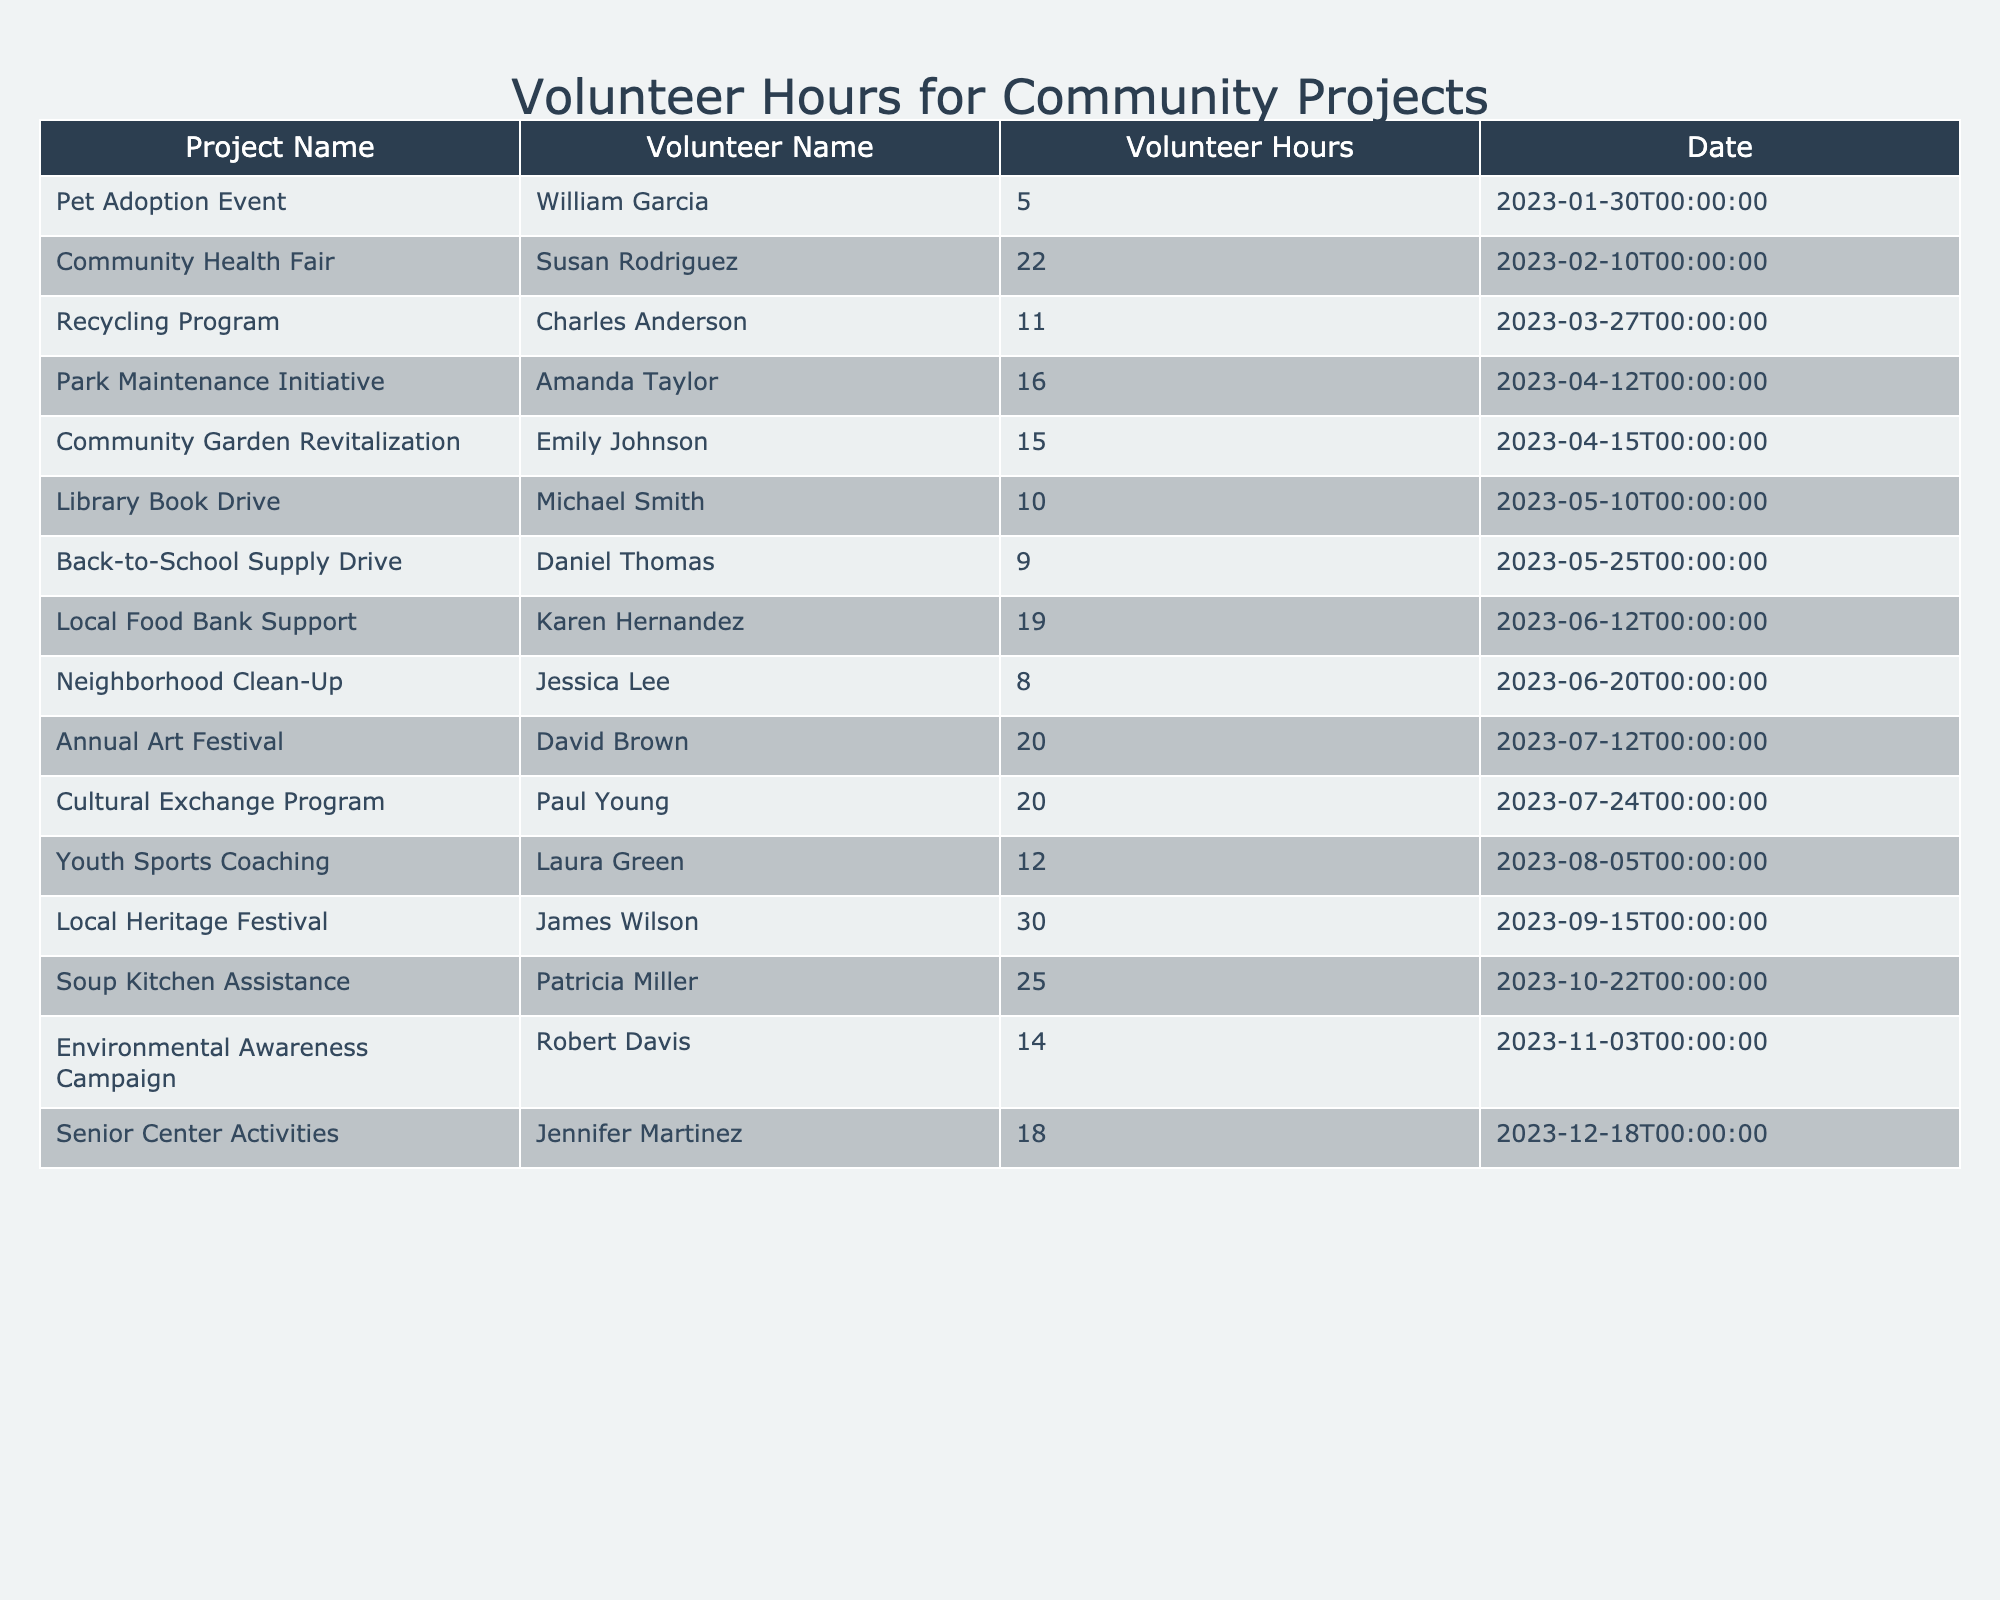What is the total number of volunteer hours logged for the Community Garden Revitalization project? The table shows that Emily Johnson logged 15 hours for the Community Garden Revitalization project. Since this is the only entry for this project, the total is 15 hours.
Answer: 15 Which project had the highest number of volunteer hours logged? By comparing the hours in the table, the Local Heritage Festival logged the most hours with 30.
Answer: 30 How many volunteer hours were logged during the month of March? The table lists volunteer hours for two projects in March: Recycling Program (11 hours) and Community Health Fair (22 hours). Their total is 11 + 22 = 33 hours.
Answer: 33 Who volunteered the most hours? The Local Heritage Festival had James Wilson logging 30 hours. This is the highest individual entry in the table.
Answer: James Wilson Is there a project with exactly 20 volunteer hours logged? Yes, both the Annual Art Festival and Cultural Exchange Program had exactly 20 hours logged.
Answer: Yes What is the average number of hours logged across all projects in the table? Adding all the hours gives a total of 15 + 10 + 8 + 20 + 12 + 30 + 25 + 14 + 18 + 5 + 22 + 11 + 16 + 9 + 19 + 20 =  320. There are 16 projects, so the average is 320/16 = 20.
Answer: 20 How many unique volunteers participated in the events? The table lists 16 volunteer names, and each name is unique according to the entries, resulting in a count of 16 unique volunteers.
Answer: 16 What percentage of the total volunteer hours does the Soup Kitchen Assistance account for? The total volunteer hours are 320, and the Soup Kitchen Assistance recorded 25 hours. The percentage is (25/320) * 100 = 7.81%.
Answer: 7.81% What is the difference in volunteer hours between the highest and lowest logged projects? The highest project (Local Heritage Festival) has 30 hours, and the lowest project (Pet Adoption Event) has 5 hours. The difference is 30 - 5 = 25 hours.
Answer: 25 